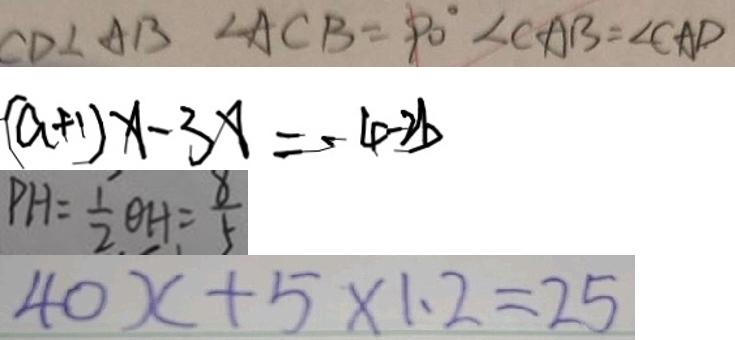Convert formula to latex. <formula><loc_0><loc_0><loc_500><loc_500>C D \bot A B \angle A C B = 9 0 ^ { \circ } \angle C A B = \angle C A D 
 ( a + 1 ) x - 3 x = - 4 - 2 b 
 P H = \frac { 1 } { 2 } \theta H = \frac { 8 } { 5 } 
 4 0 x + 5 \times 1 . 2 = 2 5</formula> 